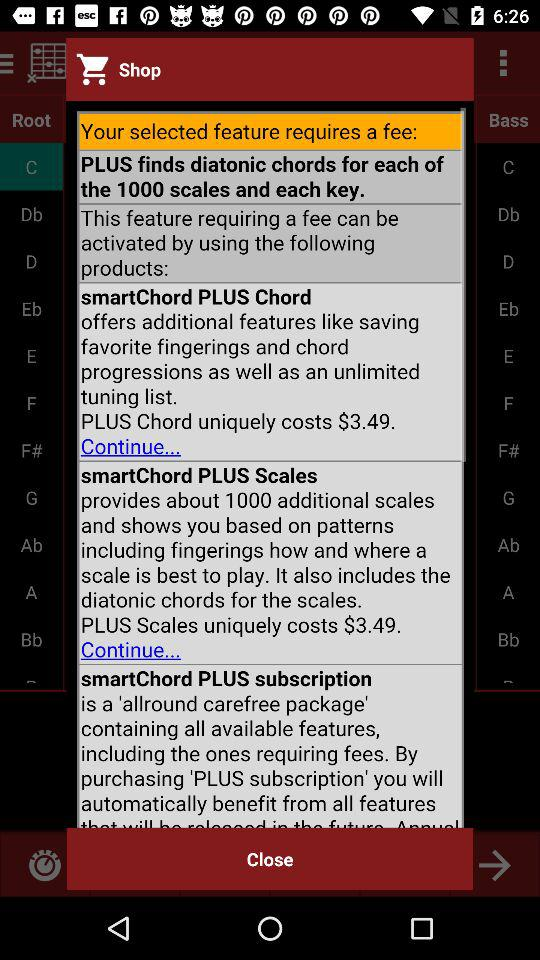What are the additional features that the "PLUS Chord" offers? The additional features that the "PLUS Chord" offers are saving favorite fingerings and chord progressions, as well as an unlimited tuning list. 